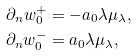<formula> <loc_0><loc_0><loc_500><loc_500>\partial _ { n } w _ { 0 } ^ { + } & = - a _ { 0 } \lambda \mu _ { \lambda } , \\ \partial _ { n } w _ { 0 } ^ { - } & = a _ { 0 } \lambda \mu _ { \lambda } ,</formula> 